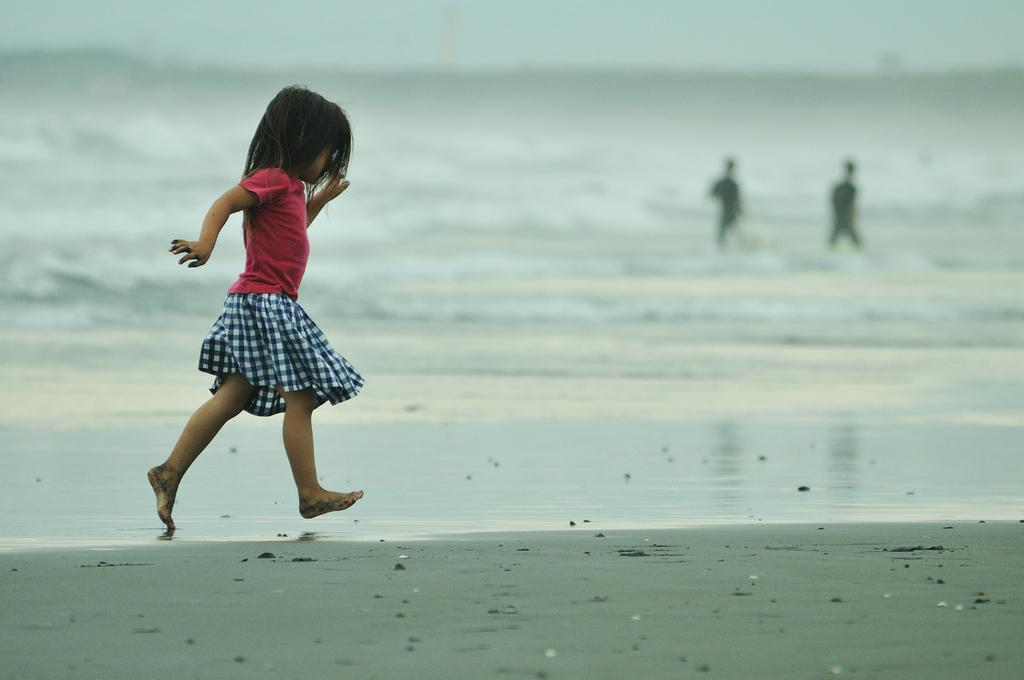What is the girl in the image doing? The girl is running on sand in the image. How many people are present in the image? There are two people in the image. What can be seen in the background of the image? The sky is visible in the background of the image. What natural element is present in the image? Water is visible in the image. What type of jar can be seen in the image? There is no jar present in the image. What flavor of pie is being eaten by the girl in the image? There is no pie present in the image; the girl is running on sand. 